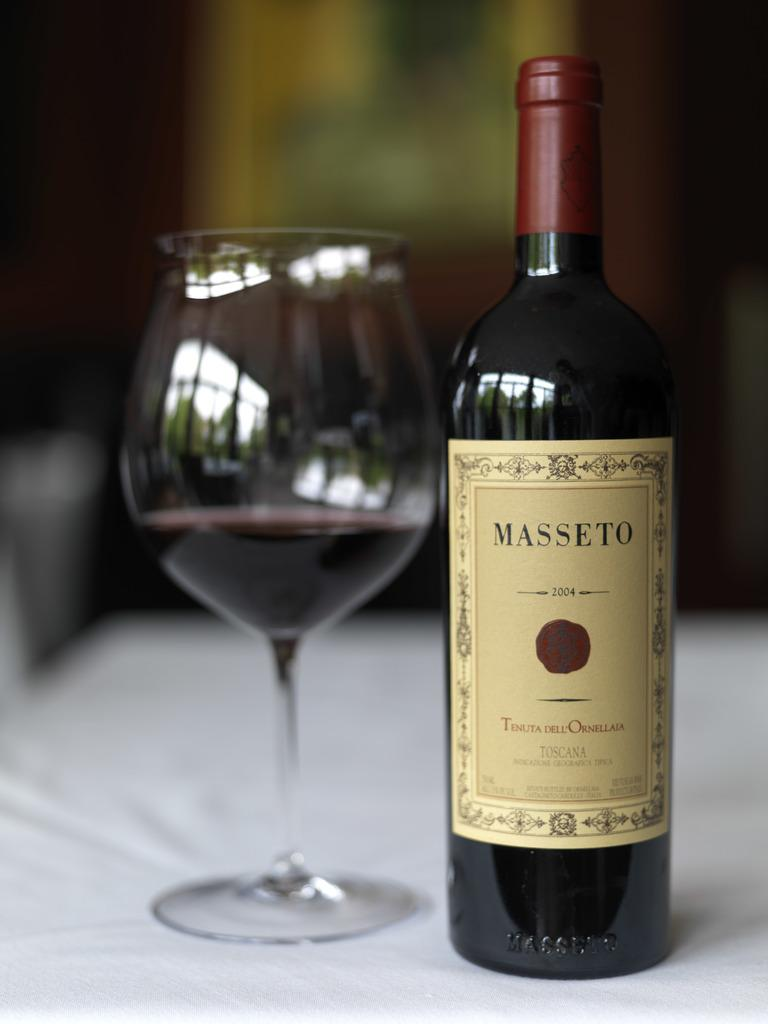What is one of the objects visible in the image? There is a glass in the image. What can be seen alongside the glass? There is a bottle with a label in the image. What information is provided on the bottle? The bottle has text on it. On what surface are the glass, bottle, and text placed? The glass, bottle, and text are placed on a surface. What type of potato is being washed in the basin in the image? There is no potato or basin present in the image; it only features a glass, a bottle, and text on a surface. 